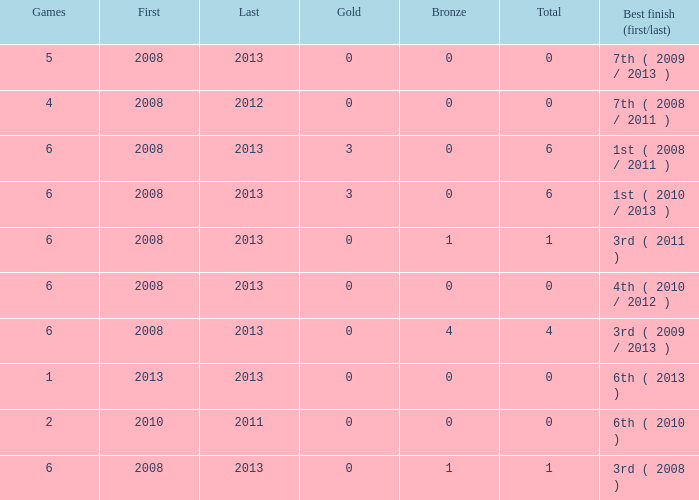What is the latest first year with 0 total medals and over 0 golds? 2008.0. 